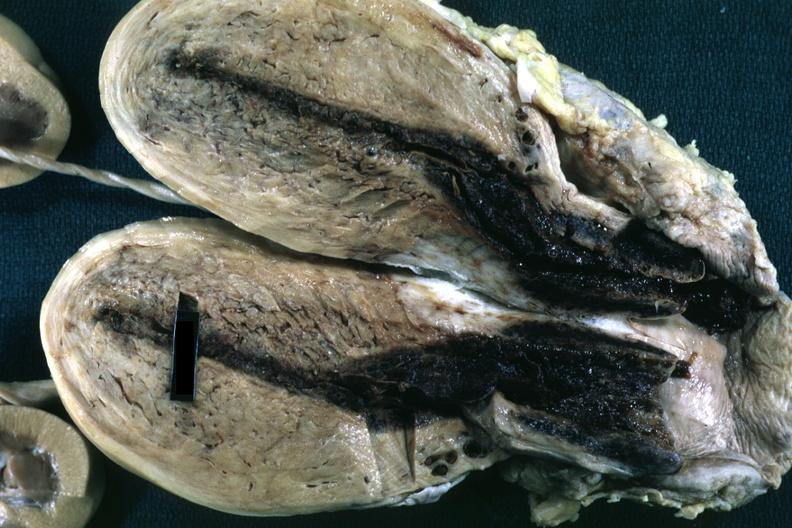s eosinophilic adenoma opened uterus with blood clot in cervical canal and small endometrial cavity?
Answer the question using a single word or phrase. No 